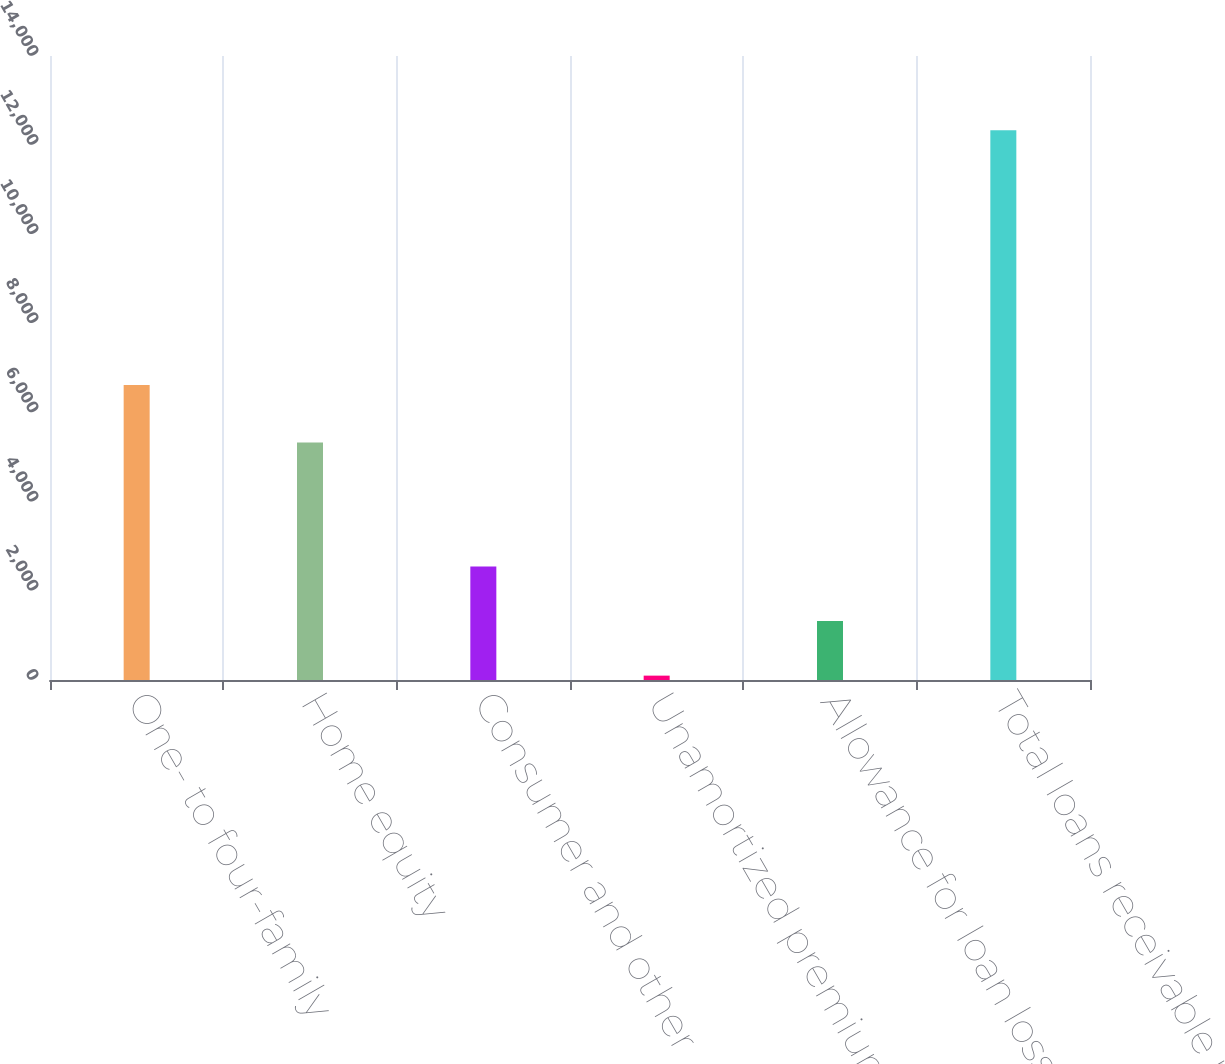<chart> <loc_0><loc_0><loc_500><loc_500><bar_chart><fcel>One- to four-family<fcel>Home equity<fcel>Consumer and other<fcel>Unamortized premiums net<fcel>Allowance for loan losses<fcel>Total loans receivable net<nl><fcel>6615.8<fcel>5328.7<fcel>2544.88<fcel>97.9<fcel>1321.39<fcel>12332.8<nl></chart> 